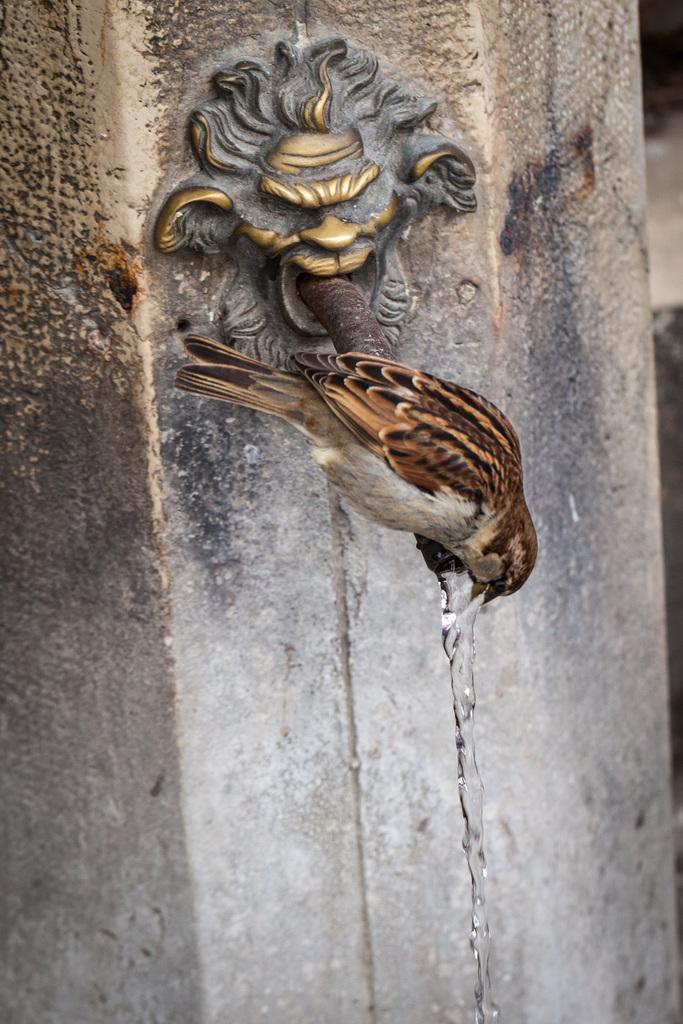What structure can be seen in the image? There is a pillar in the image. What type of animal is present in the image? There is a bird in the image. Where is the bird located in relation to the pillar? The bird is sitting on a metal rod. What type of meal is the giraffe eating in the image? There is no giraffe present in the image, and therefore no meal can be observed. 